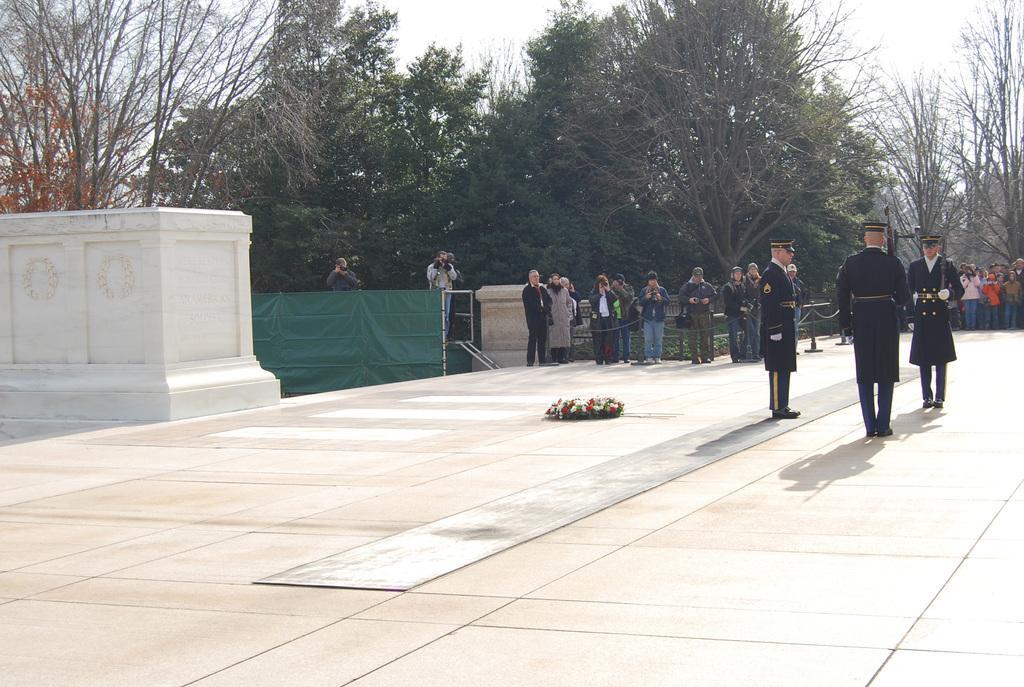Please provide a concise description of this image. On the right side of the image we can see three people standing. They are wearing uniforms. In the center there is a flower garland. In the background there are trees and a fence. We can see people. At the top there is sky. 